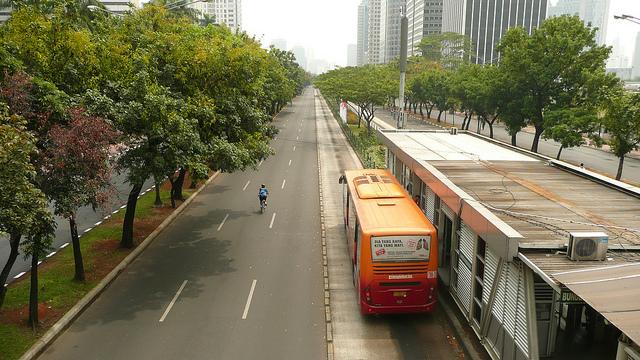What color is this train?
Give a very brief answer. Orange. Is the man alone?
Be succinct. Yes. Is the road clear?
Write a very short answer. Yes. How many bicycles are on the road?
Answer briefly. 1. What color is the bus?
Answer briefly. Orange. Are there more buses or cars in this photo?
Short answer required. Buses. Is the train short?
Short answer required. Yes. 